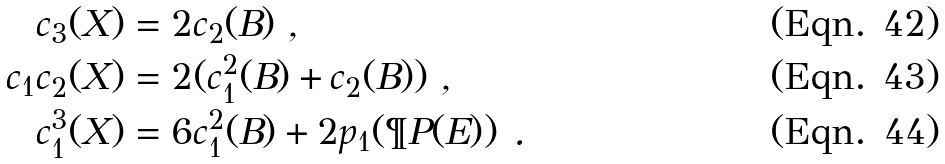Convert formula to latex. <formula><loc_0><loc_0><loc_500><loc_500>c _ { 3 } ( X ) & = 2 c _ { 2 } ( B ) \ , \\ c _ { 1 } c _ { 2 } ( X ) & = 2 ( c _ { 1 } ^ { 2 } ( B ) + c _ { 2 } ( B ) ) \ , \\ c _ { 1 } ^ { 3 } ( X ) & = 6 c _ { 1 } ^ { 2 } ( B ) + 2 p _ { 1 } ( \P P ( E ) ) \ .</formula> 